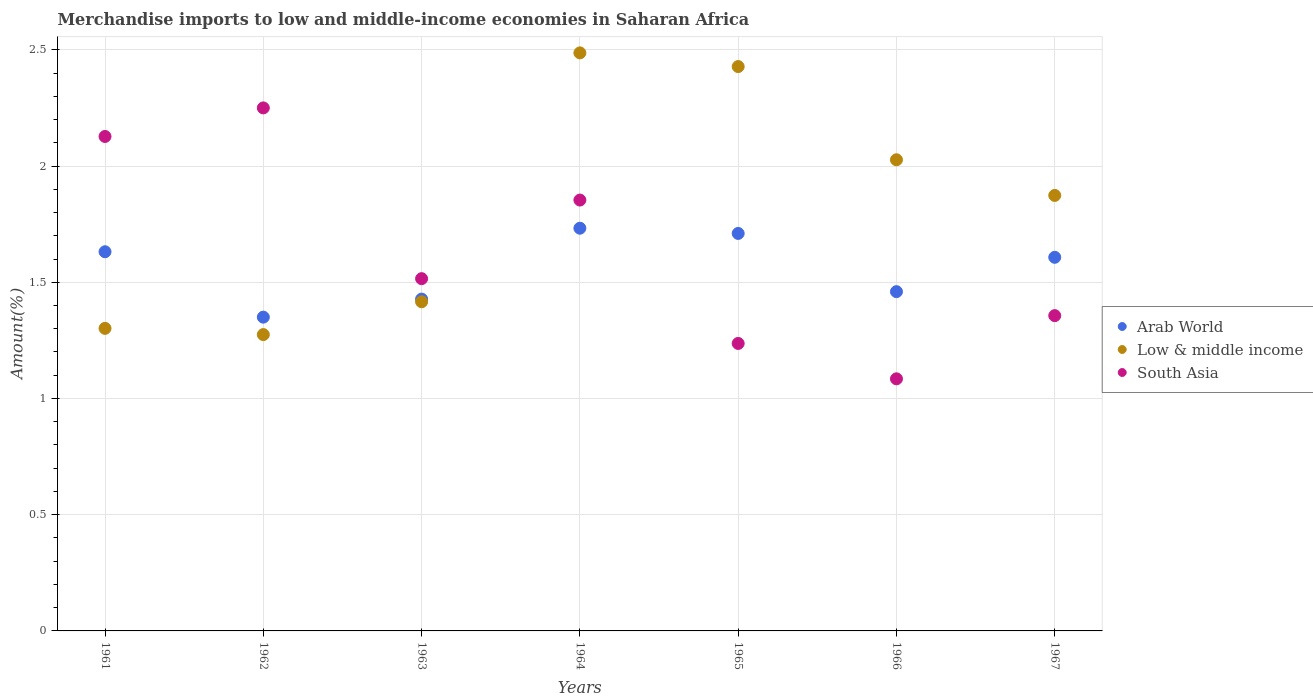How many different coloured dotlines are there?
Keep it short and to the point. 3. Is the number of dotlines equal to the number of legend labels?
Ensure brevity in your answer.  Yes. What is the percentage of amount earned from merchandise imports in Arab World in 1962?
Keep it short and to the point. 1.35. Across all years, what is the maximum percentage of amount earned from merchandise imports in South Asia?
Ensure brevity in your answer.  2.25. Across all years, what is the minimum percentage of amount earned from merchandise imports in Arab World?
Offer a very short reply. 1.35. In which year was the percentage of amount earned from merchandise imports in Low & middle income maximum?
Provide a succinct answer. 1964. What is the total percentage of amount earned from merchandise imports in South Asia in the graph?
Your answer should be compact. 11.42. What is the difference between the percentage of amount earned from merchandise imports in Arab World in 1962 and that in 1966?
Make the answer very short. -0.11. What is the difference between the percentage of amount earned from merchandise imports in South Asia in 1967 and the percentage of amount earned from merchandise imports in Arab World in 1962?
Keep it short and to the point. 0.01. What is the average percentage of amount earned from merchandise imports in South Asia per year?
Give a very brief answer. 1.63. In the year 1963, what is the difference between the percentage of amount earned from merchandise imports in Low & middle income and percentage of amount earned from merchandise imports in Arab World?
Offer a very short reply. -0.01. What is the ratio of the percentage of amount earned from merchandise imports in South Asia in 1961 to that in 1962?
Your answer should be very brief. 0.95. Is the percentage of amount earned from merchandise imports in Low & middle income in 1965 less than that in 1967?
Offer a terse response. No. What is the difference between the highest and the second highest percentage of amount earned from merchandise imports in Arab World?
Your answer should be compact. 0.02. What is the difference between the highest and the lowest percentage of amount earned from merchandise imports in South Asia?
Your answer should be very brief. 1.17. Does the percentage of amount earned from merchandise imports in Low & middle income monotonically increase over the years?
Keep it short and to the point. No. Is the percentage of amount earned from merchandise imports in Low & middle income strictly greater than the percentage of amount earned from merchandise imports in South Asia over the years?
Make the answer very short. No. How many dotlines are there?
Your answer should be compact. 3. What is the difference between two consecutive major ticks on the Y-axis?
Give a very brief answer. 0.5. Does the graph contain any zero values?
Keep it short and to the point. No. What is the title of the graph?
Offer a very short reply. Merchandise imports to low and middle-income economies in Saharan Africa. What is the label or title of the X-axis?
Your response must be concise. Years. What is the label or title of the Y-axis?
Provide a short and direct response. Amount(%). What is the Amount(%) in Arab World in 1961?
Give a very brief answer. 1.63. What is the Amount(%) in Low & middle income in 1961?
Keep it short and to the point. 1.3. What is the Amount(%) of South Asia in 1961?
Give a very brief answer. 2.13. What is the Amount(%) of Arab World in 1962?
Provide a succinct answer. 1.35. What is the Amount(%) in Low & middle income in 1962?
Make the answer very short. 1.27. What is the Amount(%) in South Asia in 1962?
Make the answer very short. 2.25. What is the Amount(%) of Arab World in 1963?
Provide a short and direct response. 1.43. What is the Amount(%) of Low & middle income in 1963?
Offer a terse response. 1.42. What is the Amount(%) of South Asia in 1963?
Your answer should be very brief. 1.52. What is the Amount(%) in Arab World in 1964?
Provide a short and direct response. 1.73. What is the Amount(%) of Low & middle income in 1964?
Give a very brief answer. 2.49. What is the Amount(%) of South Asia in 1964?
Offer a very short reply. 1.85. What is the Amount(%) in Arab World in 1965?
Your answer should be compact. 1.71. What is the Amount(%) in Low & middle income in 1965?
Offer a terse response. 2.43. What is the Amount(%) in South Asia in 1965?
Your response must be concise. 1.24. What is the Amount(%) of Arab World in 1966?
Give a very brief answer. 1.46. What is the Amount(%) of Low & middle income in 1966?
Your response must be concise. 2.03. What is the Amount(%) in South Asia in 1966?
Keep it short and to the point. 1.08. What is the Amount(%) of Arab World in 1967?
Make the answer very short. 1.61. What is the Amount(%) of Low & middle income in 1967?
Your response must be concise. 1.87. What is the Amount(%) in South Asia in 1967?
Provide a succinct answer. 1.36. Across all years, what is the maximum Amount(%) of Arab World?
Your response must be concise. 1.73. Across all years, what is the maximum Amount(%) of Low & middle income?
Your answer should be very brief. 2.49. Across all years, what is the maximum Amount(%) of South Asia?
Provide a short and direct response. 2.25. Across all years, what is the minimum Amount(%) of Arab World?
Provide a short and direct response. 1.35. Across all years, what is the minimum Amount(%) in Low & middle income?
Your response must be concise. 1.27. Across all years, what is the minimum Amount(%) of South Asia?
Ensure brevity in your answer.  1.08. What is the total Amount(%) of Arab World in the graph?
Provide a short and direct response. 10.92. What is the total Amount(%) of Low & middle income in the graph?
Keep it short and to the point. 12.81. What is the total Amount(%) of South Asia in the graph?
Give a very brief answer. 11.42. What is the difference between the Amount(%) in Arab World in 1961 and that in 1962?
Provide a succinct answer. 0.28. What is the difference between the Amount(%) of Low & middle income in 1961 and that in 1962?
Offer a terse response. 0.03. What is the difference between the Amount(%) in South Asia in 1961 and that in 1962?
Provide a short and direct response. -0.12. What is the difference between the Amount(%) in Arab World in 1961 and that in 1963?
Provide a short and direct response. 0.2. What is the difference between the Amount(%) of Low & middle income in 1961 and that in 1963?
Provide a succinct answer. -0.11. What is the difference between the Amount(%) of South Asia in 1961 and that in 1963?
Provide a succinct answer. 0.61. What is the difference between the Amount(%) in Arab World in 1961 and that in 1964?
Keep it short and to the point. -0.1. What is the difference between the Amount(%) in Low & middle income in 1961 and that in 1964?
Your response must be concise. -1.19. What is the difference between the Amount(%) in South Asia in 1961 and that in 1964?
Give a very brief answer. 0.27. What is the difference between the Amount(%) of Arab World in 1961 and that in 1965?
Offer a very short reply. -0.08. What is the difference between the Amount(%) of Low & middle income in 1961 and that in 1965?
Make the answer very short. -1.13. What is the difference between the Amount(%) in South Asia in 1961 and that in 1965?
Offer a terse response. 0.89. What is the difference between the Amount(%) in Arab World in 1961 and that in 1966?
Offer a terse response. 0.17. What is the difference between the Amount(%) of Low & middle income in 1961 and that in 1966?
Ensure brevity in your answer.  -0.73. What is the difference between the Amount(%) of South Asia in 1961 and that in 1966?
Your answer should be very brief. 1.04. What is the difference between the Amount(%) of Arab World in 1961 and that in 1967?
Your answer should be compact. 0.02. What is the difference between the Amount(%) of Low & middle income in 1961 and that in 1967?
Your answer should be very brief. -0.57. What is the difference between the Amount(%) in South Asia in 1961 and that in 1967?
Your answer should be compact. 0.77. What is the difference between the Amount(%) of Arab World in 1962 and that in 1963?
Offer a terse response. -0.08. What is the difference between the Amount(%) of Low & middle income in 1962 and that in 1963?
Provide a succinct answer. -0.14. What is the difference between the Amount(%) in South Asia in 1962 and that in 1963?
Give a very brief answer. 0.73. What is the difference between the Amount(%) in Arab World in 1962 and that in 1964?
Ensure brevity in your answer.  -0.38. What is the difference between the Amount(%) of Low & middle income in 1962 and that in 1964?
Offer a terse response. -1.21. What is the difference between the Amount(%) in South Asia in 1962 and that in 1964?
Provide a short and direct response. 0.4. What is the difference between the Amount(%) of Arab World in 1962 and that in 1965?
Offer a very short reply. -0.36. What is the difference between the Amount(%) of Low & middle income in 1962 and that in 1965?
Your answer should be very brief. -1.15. What is the difference between the Amount(%) of South Asia in 1962 and that in 1965?
Offer a terse response. 1.01. What is the difference between the Amount(%) in Arab World in 1962 and that in 1966?
Offer a very short reply. -0.11. What is the difference between the Amount(%) in Low & middle income in 1962 and that in 1966?
Your response must be concise. -0.75. What is the difference between the Amount(%) in South Asia in 1962 and that in 1966?
Your answer should be compact. 1.17. What is the difference between the Amount(%) of Arab World in 1962 and that in 1967?
Offer a very short reply. -0.26. What is the difference between the Amount(%) in Low & middle income in 1962 and that in 1967?
Ensure brevity in your answer.  -0.6. What is the difference between the Amount(%) in South Asia in 1962 and that in 1967?
Provide a succinct answer. 0.89. What is the difference between the Amount(%) in Arab World in 1963 and that in 1964?
Make the answer very short. -0.3. What is the difference between the Amount(%) in Low & middle income in 1963 and that in 1964?
Your response must be concise. -1.07. What is the difference between the Amount(%) of South Asia in 1963 and that in 1964?
Your answer should be very brief. -0.34. What is the difference between the Amount(%) in Arab World in 1963 and that in 1965?
Make the answer very short. -0.28. What is the difference between the Amount(%) of Low & middle income in 1963 and that in 1965?
Your response must be concise. -1.01. What is the difference between the Amount(%) in South Asia in 1963 and that in 1965?
Keep it short and to the point. 0.28. What is the difference between the Amount(%) in Arab World in 1963 and that in 1966?
Offer a terse response. -0.03. What is the difference between the Amount(%) of Low & middle income in 1963 and that in 1966?
Make the answer very short. -0.61. What is the difference between the Amount(%) of South Asia in 1963 and that in 1966?
Make the answer very short. 0.43. What is the difference between the Amount(%) of Arab World in 1963 and that in 1967?
Your response must be concise. -0.18. What is the difference between the Amount(%) in Low & middle income in 1963 and that in 1967?
Your answer should be compact. -0.46. What is the difference between the Amount(%) in South Asia in 1963 and that in 1967?
Keep it short and to the point. 0.16. What is the difference between the Amount(%) of Arab World in 1964 and that in 1965?
Give a very brief answer. 0.02. What is the difference between the Amount(%) of Low & middle income in 1964 and that in 1965?
Your answer should be compact. 0.06. What is the difference between the Amount(%) in South Asia in 1964 and that in 1965?
Give a very brief answer. 0.62. What is the difference between the Amount(%) of Arab World in 1964 and that in 1966?
Provide a succinct answer. 0.27. What is the difference between the Amount(%) of Low & middle income in 1964 and that in 1966?
Your answer should be compact. 0.46. What is the difference between the Amount(%) of South Asia in 1964 and that in 1966?
Your answer should be very brief. 0.77. What is the difference between the Amount(%) in Arab World in 1964 and that in 1967?
Offer a terse response. 0.13. What is the difference between the Amount(%) of Low & middle income in 1964 and that in 1967?
Offer a very short reply. 0.61. What is the difference between the Amount(%) in South Asia in 1964 and that in 1967?
Offer a terse response. 0.5. What is the difference between the Amount(%) in Arab World in 1965 and that in 1966?
Offer a very short reply. 0.25. What is the difference between the Amount(%) in Low & middle income in 1965 and that in 1966?
Provide a succinct answer. 0.4. What is the difference between the Amount(%) of South Asia in 1965 and that in 1966?
Your response must be concise. 0.15. What is the difference between the Amount(%) of Arab World in 1965 and that in 1967?
Make the answer very short. 0.1. What is the difference between the Amount(%) of Low & middle income in 1965 and that in 1967?
Keep it short and to the point. 0.55. What is the difference between the Amount(%) in South Asia in 1965 and that in 1967?
Keep it short and to the point. -0.12. What is the difference between the Amount(%) in Arab World in 1966 and that in 1967?
Offer a very short reply. -0.15. What is the difference between the Amount(%) in Low & middle income in 1966 and that in 1967?
Your answer should be very brief. 0.15. What is the difference between the Amount(%) of South Asia in 1966 and that in 1967?
Your answer should be compact. -0.27. What is the difference between the Amount(%) of Arab World in 1961 and the Amount(%) of Low & middle income in 1962?
Provide a succinct answer. 0.36. What is the difference between the Amount(%) of Arab World in 1961 and the Amount(%) of South Asia in 1962?
Your answer should be compact. -0.62. What is the difference between the Amount(%) in Low & middle income in 1961 and the Amount(%) in South Asia in 1962?
Offer a very short reply. -0.95. What is the difference between the Amount(%) in Arab World in 1961 and the Amount(%) in Low & middle income in 1963?
Offer a terse response. 0.22. What is the difference between the Amount(%) in Arab World in 1961 and the Amount(%) in South Asia in 1963?
Make the answer very short. 0.12. What is the difference between the Amount(%) of Low & middle income in 1961 and the Amount(%) of South Asia in 1963?
Offer a terse response. -0.21. What is the difference between the Amount(%) in Arab World in 1961 and the Amount(%) in Low & middle income in 1964?
Offer a very short reply. -0.86. What is the difference between the Amount(%) in Arab World in 1961 and the Amount(%) in South Asia in 1964?
Offer a very short reply. -0.22. What is the difference between the Amount(%) of Low & middle income in 1961 and the Amount(%) of South Asia in 1964?
Your response must be concise. -0.55. What is the difference between the Amount(%) of Arab World in 1961 and the Amount(%) of Low & middle income in 1965?
Your response must be concise. -0.8. What is the difference between the Amount(%) in Arab World in 1961 and the Amount(%) in South Asia in 1965?
Your answer should be compact. 0.39. What is the difference between the Amount(%) of Low & middle income in 1961 and the Amount(%) of South Asia in 1965?
Offer a terse response. 0.06. What is the difference between the Amount(%) of Arab World in 1961 and the Amount(%) of Low & middle income in 1966?
Provide a succinct answer. -0.4. What is the difference between the Amount(%) in Arab World in 1961 and the Amount(%) in South Asia in 1966?
Provide a short and direct response. 0.55. What is the difference between the Amount(%) in Low & middle income in 1961 and the Amount(%) in South Asia in 1966?
Your response must be concise. 0.22. What is the difference between the Amount(%) in Arab World in 1961 and the Amount(%) in Low & middle income in 1967?
Give a very brief answer. -0.24. What is the difference between the Amount(%) of Arab World in 1961 and the Amount(%) of South Asia in 1967?
Offer a very short reply. 0.27. What is the difference between the Amount(%) in Low & middle income in 1961 and the Amount(%) in South Asia in 1967?
Give a very brief answer. -0.05. What is the difference between the Amount(%) of Arab World in 1962 and the Amount(%) of Low & middle income in 1963?
Offer a terse response. -0.07. What is the difference between the Amount(%) of Arab World in 1962 and the Amount(%) of South Asia in 1963?
Give a very brief answer. -0.17. What is the difference between the Amount(%) of Low & middle income in 1962 and the Amount(%) of South Asia in 1963?
Offer a very short reply. -0.24. What is the difference between the Amount(%) of Arab World in 1962 and the Amount(%) of Low & middle income in 1964?
Your response must be concise. -1.14. What is the difference between the Amount(%) in Arab World in 1962 and the Amount(%) in South Asia in 1964?
Keep it short and to the point. -0.5. What is the difference between the Amount(%) of Low & middle income in 1962 and the Amount(%) of South Asia in 1964?
Your answer should be very brief. -0.58. What is the difference between the Amount(%) in Arab World in 1962 and the Amount(%) in Low & middle income in 1965?
Keep it short and to the point. -1.08. What is the difference between the Amount(%) in Arab World in 1962 and the Amount(%) in South Asia in 1965?
Offer a very short reply. 0.11. What is the difference between the Amount(%) in Low & middle income in 1962 and the Amount(%) in South Asia in 1965?
Your answer should be compact. 0.04. What is the difference between the Amount(%) in Arab World in 1962 and the Amount(%) in Low & middle income in 1966?
Ensure brevity in your answer.  -0.68. What is the difference between the Amount(%) in Arab World in 1962 and the Amount(%) in South Asia in 1966?
Your answer should be very brief. 0.27. What is the difference between the Amount(%) of Low & middle income in 1962 and the Amount(%) of South Asia in 1966?
Offer a terse response. 0.19. What is the difference between the Amount(%) in Arab World in 1962 and the Amount(%) in Low & middle income in 1967?
Make the answer very short. -0.52. What is the difference between the Amount(%) of Arab World in 1962 and the Amount(%) of South Asia in 1967?
Give a very brief answer. -0.01. What is the difference between the Amount(%) of Low & middle income in 1962 and the Amount(%) of South Asia in 1967?
Provide a succinct answer. -0.08. What is the difference between the Amount(%) in Arab World in 1963 and the Amount(%) in Low & middle income in 1964?
Your answer should be very brief. -1.06. What is the difference between the Amount(%) of Arab World in 1963 and the Amount(%) of South Asia in 1964?
Provide a short and direct response. -0.43. What is the difference between the Amount(%) in Low & middle income in 1963 and the Amount(%) in South Asia in 1964?
Offer a very short reply. -0.44. What is the difference between the Amount(%) of Arab World in 1963 and the Amount(%) of Low & middle income in 1965?
Offer a very short reply. -1. What is the difference between the Amount(%) of Arab World in 1963 and the Amount(%) of South Asia in 1965?
Your answer should be compact. 0.19. What is the difference between the Amount(%) of Low & middle income in 1963 and the Amount(%) of South Asia in 1965?
Ensure brevity in your answer.  0.18. What is the difference between the Amount(%) of Arab World in 1963 and the Amount(%) of Low & middle income in 1966?
Your response must be concise. -0.6. What is the difference between the Amount(%) in Arab World in 1963 and the Amount(%) in South Asia in 1966?
Ensure brevity in your answer.  0.34. What is the difference between the Amount(%) in Low & middle income in 1963 and the Amount(%) in South Asia in 1966?
Make the answer very short. 0.33. What is the difference between the Amount(%) of Arab World in 1963 and the Amount(%) of Low & middle income in 1967?
Your response must be concise. -0.45. What is the difference between the Amount(%) of Arab World in 1963 and the Amount(%) of South Asia in 1967?
Provide a succinct answer. 0.07. What is the difference between the Amount(%) of Low & middle income in 1963 and the Amount(%) of South Asia in 1967?
Your response must be concise. 0.06. What is the difference between the Amount(%) in Arab World in 1964 and the Amount(%) in Low & middle income in 1965?
Your answer should be very brief. -0.7. What is the difference between the Amount(%) in Arab World in 1964 and the Amount(%) in South Asia in 1965?
Provide a short and direct response. 0.5. What is the difference between the Amount(%) in Low & middle income in 1964 and the Amount(%) in South Asia in 1965?
Provide a short and direct response. 1.25. What is the difference between the Amount(%) of Arab World in 1964 and the Amount(%) of Low & middle income in 1966?
Keep it short and to the point. -0.29. What is the difference between the Amount(%) in Arab World in 1964 and the Amount(%) in South Asia in 1966?
Provide a succinct answer. 0.65. What is the difference between the Amount(%) in Low & middle income in 1964 and the Amount(%) in South Asia in 1966?
Make the answer very short. 1.4. What is the difference between the Amount(%) in Arab World in 1964 and the Amount(%) in Low & middle income in 1967?
Your answer should be compact. -0.14. What is the difference between the Amount(%) of Arab World in 1964 and the Amount(%) of South Asia in 1967?
Keep it short and to the point. 0.38. What is the difference between the Amount(%) of Low & middle income in 1964 and the Amount(%) of South Asia in 1967?
Your answer should be compact. 1.13. What is the difference between the Amount(%) in Arab World in 1965 and the Amount(%) in Low & middle income in 1966?
Keep it short and to the point. -0.32. What is the difference between the Amount(%) in Arab World in 1965 and the Amount(%) in South Asia in 1966?
Provide a short and direct response. 0.63. What is the difference between the Amount(%) of Low & middle income in 1965 and the Amount(%) of South Asia in 1966?
Offer a very short reply. 1.34. What is the difference between the Amount(%) of Arab World in 1965 and the Amount(%) of Low & middle income in 1967?
Keep it short and to the point. -0.16. What is the difference between the Amount(%) of Arab World in 1965 and the Amount(%) of South Asia in 1967?
Provide a succinct answer. 0.35. What is the difference between the Amount(%) of Low & middle income in 1965 and the Amount(%) of South Asia in 1967?
Offer a very short reply. 1.07. What is the difference between the Amount(%) in Arab World in 1966 and the Amount(%) in Low & middle income in 1967?
Provide a succinct answer. -0.41. What is the difference between the Amount(%) in Arab World in 1966 and the Amount(%) in South Asia in 1967?
Make the answer very short. 0.1. What is the difference between the Amount(%) in Low & middle income in 1966 and the Amount(%) in South Asia in 1967?
Ensure brevity in your answer.  0.67. What is the average Amount(%) of Arab World per year?
Make the answer very short. 1.56. What is the average Amount(%) in Low & middle income per year?
Your answer should be very brief. 1.83. What is the average Amount(%) of South Asia per year?
Your response must be concise. 1.63. In the year 1961, what is the difference between the Amount(%) of Arab World and Amount(%) of Low & middle income?
Give a very brief answer. 0.33. In the year 1961, what is the difference between the Amount(%) of Arab World and Amount(%) of South Asia?
Provide a succinct answer. -0.5. In the year 1961, what is the difference between the Amount(%) of Low & middle income and Amount(%) of South Asia?
Your answer should be compact. -0.83. In the year 1962, what is the difference between the Amount(%) in Arab World and Amount(%) in Low & middle income?
Provide a short and direct response. 0.07. In the year 1962, what is the difference between the Amount(%) of Arab World and Amount(%) of South Asia?
Provide a succinct answer. -0.9. In the year 1962, what is the difference between the Amount(%) in Low & middle income and Amount(%) in South Asia?
Keep it short and to the point. -0.98. In the year 1963, what is the difference between the Amount(%) of Arab World and Amount(%) of Low & middle income?
Offer a very short reply. 0.01. In the year 1963, what is the difference between the Amount(%) in Arab World and Amount(%) in South Asia?
Keep it short and to the point. -0.09. In the year 1963, what is the difference between the Amount(%) in Low & middle income and Amount(%) in South Asia?
Offer a very short reply. -0.1. In the year 1964, what is the difference between the Amount(%) in Arab World and Amount(%) in Low & middle income?
Make the answer very short. -0.75. In the year 1964, what is the difference between the Amount(%) in Arab World and Amount(%) in South Asia?
Give a very brief answer. -0.12. In the year 1964, what is the difference between the Amount(%) in Low & middle income and Amount(%) in South Asia?
Offer a very short reply. 0.63. In the year 1965, what is the difference between the Amount(%) in Arab World and Amount(%) in Low & middle income?
Your answer should be very brief. -0.72. In the year 1965, what is the difference between the Amount(%) of Arab World and Amount(%) of South Asia?
Keep it short and to the point. 0.47. In the year 1965, what is the difference between the Amount(%) in Low & middle income and Amount(%) in South Asia?
Your answer should be compact. 1.19. In the year 1966, what is the difference between the Amount(%) in Arab World and Amount(%) in Low & middle income?
Ensure brevity in your answer.  -0.57. In the year 1966, what is the difference between the Amount(%) in Arab World and Amount(%) in South Asia?
Make the answer very short. 0.38. In the year 1966, what is the difference between the Amount(%) of Low & middle income and Amount(%) of South Asia?
Keep it short and to the point. 0.94. In the year 1967, what is the difference between the Amount(%) of Arab World and Amount(%) of Low & middle income?
Your answer should be very brief. -0.27. In the year 1967, what is the difference between the Amount(%) of Arab World and Amount(%) of South Asia?
Provide a short and direct response. 0.25. In the year 1967, what is the difference between the Amount(%) of Low & middle income and Amount(%) of South Asia?
Keep it short and to the point. 0.52. What is the ratio of the Amount(%) in Arab World in 1961 to that in 1962?
Offer a terse response. 1.21. What is the ratio of the Amount(%) in Low & middle income in 1961 to that in 1962?
Offer a terse response. 1.02. What is the ratio of the Amount(%) in South Asia in 1961 to that in 1962?
Your answer should be compact. 0.95. What is the ratio of the Amount(%) in Arab World in 1961 to that in 1963?
Provide a succinct answer. 1.14. What is the ratio of the Amount(%) in Low & middle income in 1961 to that in 1963?
Your answer should be very brief. 0.92. What is the ratio of the Amount(%) in South Asia in 1961 to that in 1963?
Provide a short and direct response. 1.4. What is the ratio of the Amount(%) of Arab World in 1961 to that in 1964?
Give a very brief answer. 0.94. What is the ratio of the Amount(%) of Low & middle income in 1961 to that in 1964?
Keep it short and to the point. 0.52. What is the ratio of the Amount(%) of South Asia in 1961 to that in 1964?
Offer a very short reply. 1.15. What is the ratio of the Amount(%) of Arab World in 1961 to that in 1965?
Ensure brevity in your answer.  0.95. What is the ratio of the Amount(%) of Low & middle income in 1961 to that in 1965?
Provide a succinct answer. 0.54. What is the ratio of the Amount(%) in South Asia in 1961 to that in 1965?
Provide a short and direct response. 1.72. What is the ratio of the Amount(%) of Arab World in 1961 to that in 1966?
Your answer should be compact. 1.12. What is the ratio of the Amount(%) of Low & middle income in 1961 to that in 1966?
Keep it short and to the point. 0.64. What is the ratio of the Amount(%) of South Asia in 1961 to that in 1966?
Provide a short and direct response. 1.96. What is the ratio of the Amount(%) of Arab World in 1961 to that in 1967?
Give a very brief answer. 1.01. What is the ratio of the Amount(%) of Low & middle income in 1961 to that in 1967?
Your answer should be very brief. 0.69. What is the ratio of the Amount(%) in South Asia in 1961 to that in 1967?
Ensure brevity in your answer.  1.57. What is the ratio of the Amount(%) of Arab World in 1962 to that in 1963?
Your answer should be very brief. 0.95. What is the ratio of the Amount(%) in Low & middle income in 1962 to that in 1963?
Offer a very short reply. 0.9. What is the ratio of the Amount(%) in South Asia in 1962 to that in 1963?
Your answer should be compact. 1.48. What is the ratio of the Amount(%) of Arab World in 1962 to that in 1964?
Offer a terse response. 0.78. What is the ratio of the Amount(%) in Low & middle income in 1962 to that in 1964?
Keep it short and to the point. 0.51. What is the ratio of the Amount(%) in South Asia in 1962 to that in 1964?
Offer a very short reply. 1.21. What is the ratio of the Amount(%) of Arab World in 1962 to that in 1965?
Offer a terse response. 0.79. What is the ratio of the Amount(%) of Low & middle income in 1962 to that in 1965?
Your response must be concise. 0.53. What is the ratio of the Amount(%) in South Asia in 1962 to that in 1965?
Provide a short and direct response. 1.82. What is the ratio of the Amount(%) in Arab World in 1962 to that in 1966?
Your answer should be very brief. 0.92. What is the ratio of the Amount(%) of Low & middle income in 1962 to that in 1966?
Your response must be concise. 0.63. What is the ratio of the Amount(%) of South Asia in 1962 to that in 1966?
Your answer should be compact. 2.07. What is the ratio of the Amount(%) in Arab World in 1962 to that in 1967?
Provide a short and direct response. 0.84. What is the ratio of the Amount(%) of Low & middle income in 1962 to that in 1967?
Your response must be concise. 0.68. What is the ratio of the Amount(%) of South Asia in 1962 to that in 1967?
Your answer should be very brief. 1.66. What is the ratio of the Amount(%) in Arab World in 1963 to that in 1964?
Provide a short and direct response. 0.82. What is the ratio of the Amount(%) in Low & middle income in 1963 to that in 1964?
Offer a very short reply. 0.57. What is the ratio of the Amount(%) in South Asia in 1963 to that in 1964?
Your answer should be very brief. 0.82. What is the ratio of the Amount(%) in Arab World in 1963 to that in 1965?
Ensure brevity in your answer.  0.83. What is the ratio of the Amount(%) of Low & middle income in 1963 to that in 1965?
Ensure brevity in your answer.  0.58. What is the ratio of the Amount(%) in South Asia in 1963 to that in 1965?
Your response must be concise. 1.23. What is the ratio of the Amount(%) in Low & middle income in 1963 to that in 1966?
Provide a short and direct response. 0.7. What is the ratio of the Amount(%) in South Asia in 1963 to that in 1966?
Your answer should be compact. 1.4. What is the ratio of the Amount(%) in Arab World in 1963 to that in 1967?
Offer a very short reply. 0.89. What is the ratio of the Amount(%) in Low & middle income in 1963 to that in 1967?
Keep it short and to the point. 0.76. What is the ratio of the Amount(%) of South Asia in 1963 to that in 1967?
Make the answer very short. 1.12. What is the ratio of the Amount(%) in Arab World in 1964 to that in 1965?
Provide a succinct answer. 1.01. What is the ratio of the Amount(%) of Low & middle income in 1964 to that in 1965?
Provide a short and direct response. 1.02. What is the ratio of the Amount(%) of South Asia in 1964 to that in 1965?
Keep it short and to the point. 1.5. What is the ratio of the Amount(%) of Arab World in 1964 to that in 1966?
Keep it short and to the point. 1.19. What is the ratio of the Amount(%) in Low & middle income in 1964 to that in 1966?
Give a very brief answer. 1.23. What is the ratio of the Amount(%) in South Asia in 1964 to that in 1966?
Give a very brief answer. 1.71. What is the ratio of the Amount(%) of Arab World in 1964 to that in 1967?
Ensure brevity in your answer.  1.08. What is the ratio of the Amount(%) in Low & middle income in 1964 to that in 1967?
Your answer should be compact. 1.33. What is the ratio of the Amount(%) in South Asia in 1964 to that in 1967?
Provide a succinct answer. 1.37. What is the ratio of the Amount(%) in Arab World in 1965 to that in 1966?
Give a very brief answer. 1.17. What is the ratio of the Amount(%) in Low & middle income in 1965 to that in 1966?
Your answer should be very brief. 1.2. What is the ratio of the Amount(%) in South Asia in 1965 to that in 1966?
Your response must be concise. 1.14. What is the ratio of the Amount(%) of Arab World in 1965 to that in 1967?
Keep it short and to the point. 1.06. What is the ratio of the Amount(%) of Low & middle income in 1965 to that in 1967?
Your response must be concise. 1.3. What is the ratio of the Amount(%) in South Asia in 1965 to that in 1967?
Provide a succinct answer. 0.91. What is the ratio of the Amount(%) of Arab World in 1966 to that in 1967?
Your response must be concise. 0.91. What is the ratio of the Amount(%) in Low & middle income in 1966 to that in 1967?
Provide a short and direct response. 1.08. What is the ratio of the Amount(%) of South Asia in 1966 to that in 1967?
Your answer should be very brief. 0.8. What is the difference between the highest and the second highest Amount(%) in Arab World?
Your answer should be compact. 0.02. What is the difference between the highest and the second highest Amount(%) of Low & middle income?
Ensure brevity in your answer.  0.06. What is the difference between the highest and the second highest Amount(%) in South Asia?
Offer a terse response. 0.12. What is the difference between the highest and the lowest Amount(%) in Arab World?
Make the answer very short. 0.38. What is the difference between the highest and the lowest Amount(%) in Low & middle income?
Your answer should be compact. 1.21. What is the difference between the highest and the lowest Amount(%) in South Asia?
Keep it short and to the point. 1.17. 